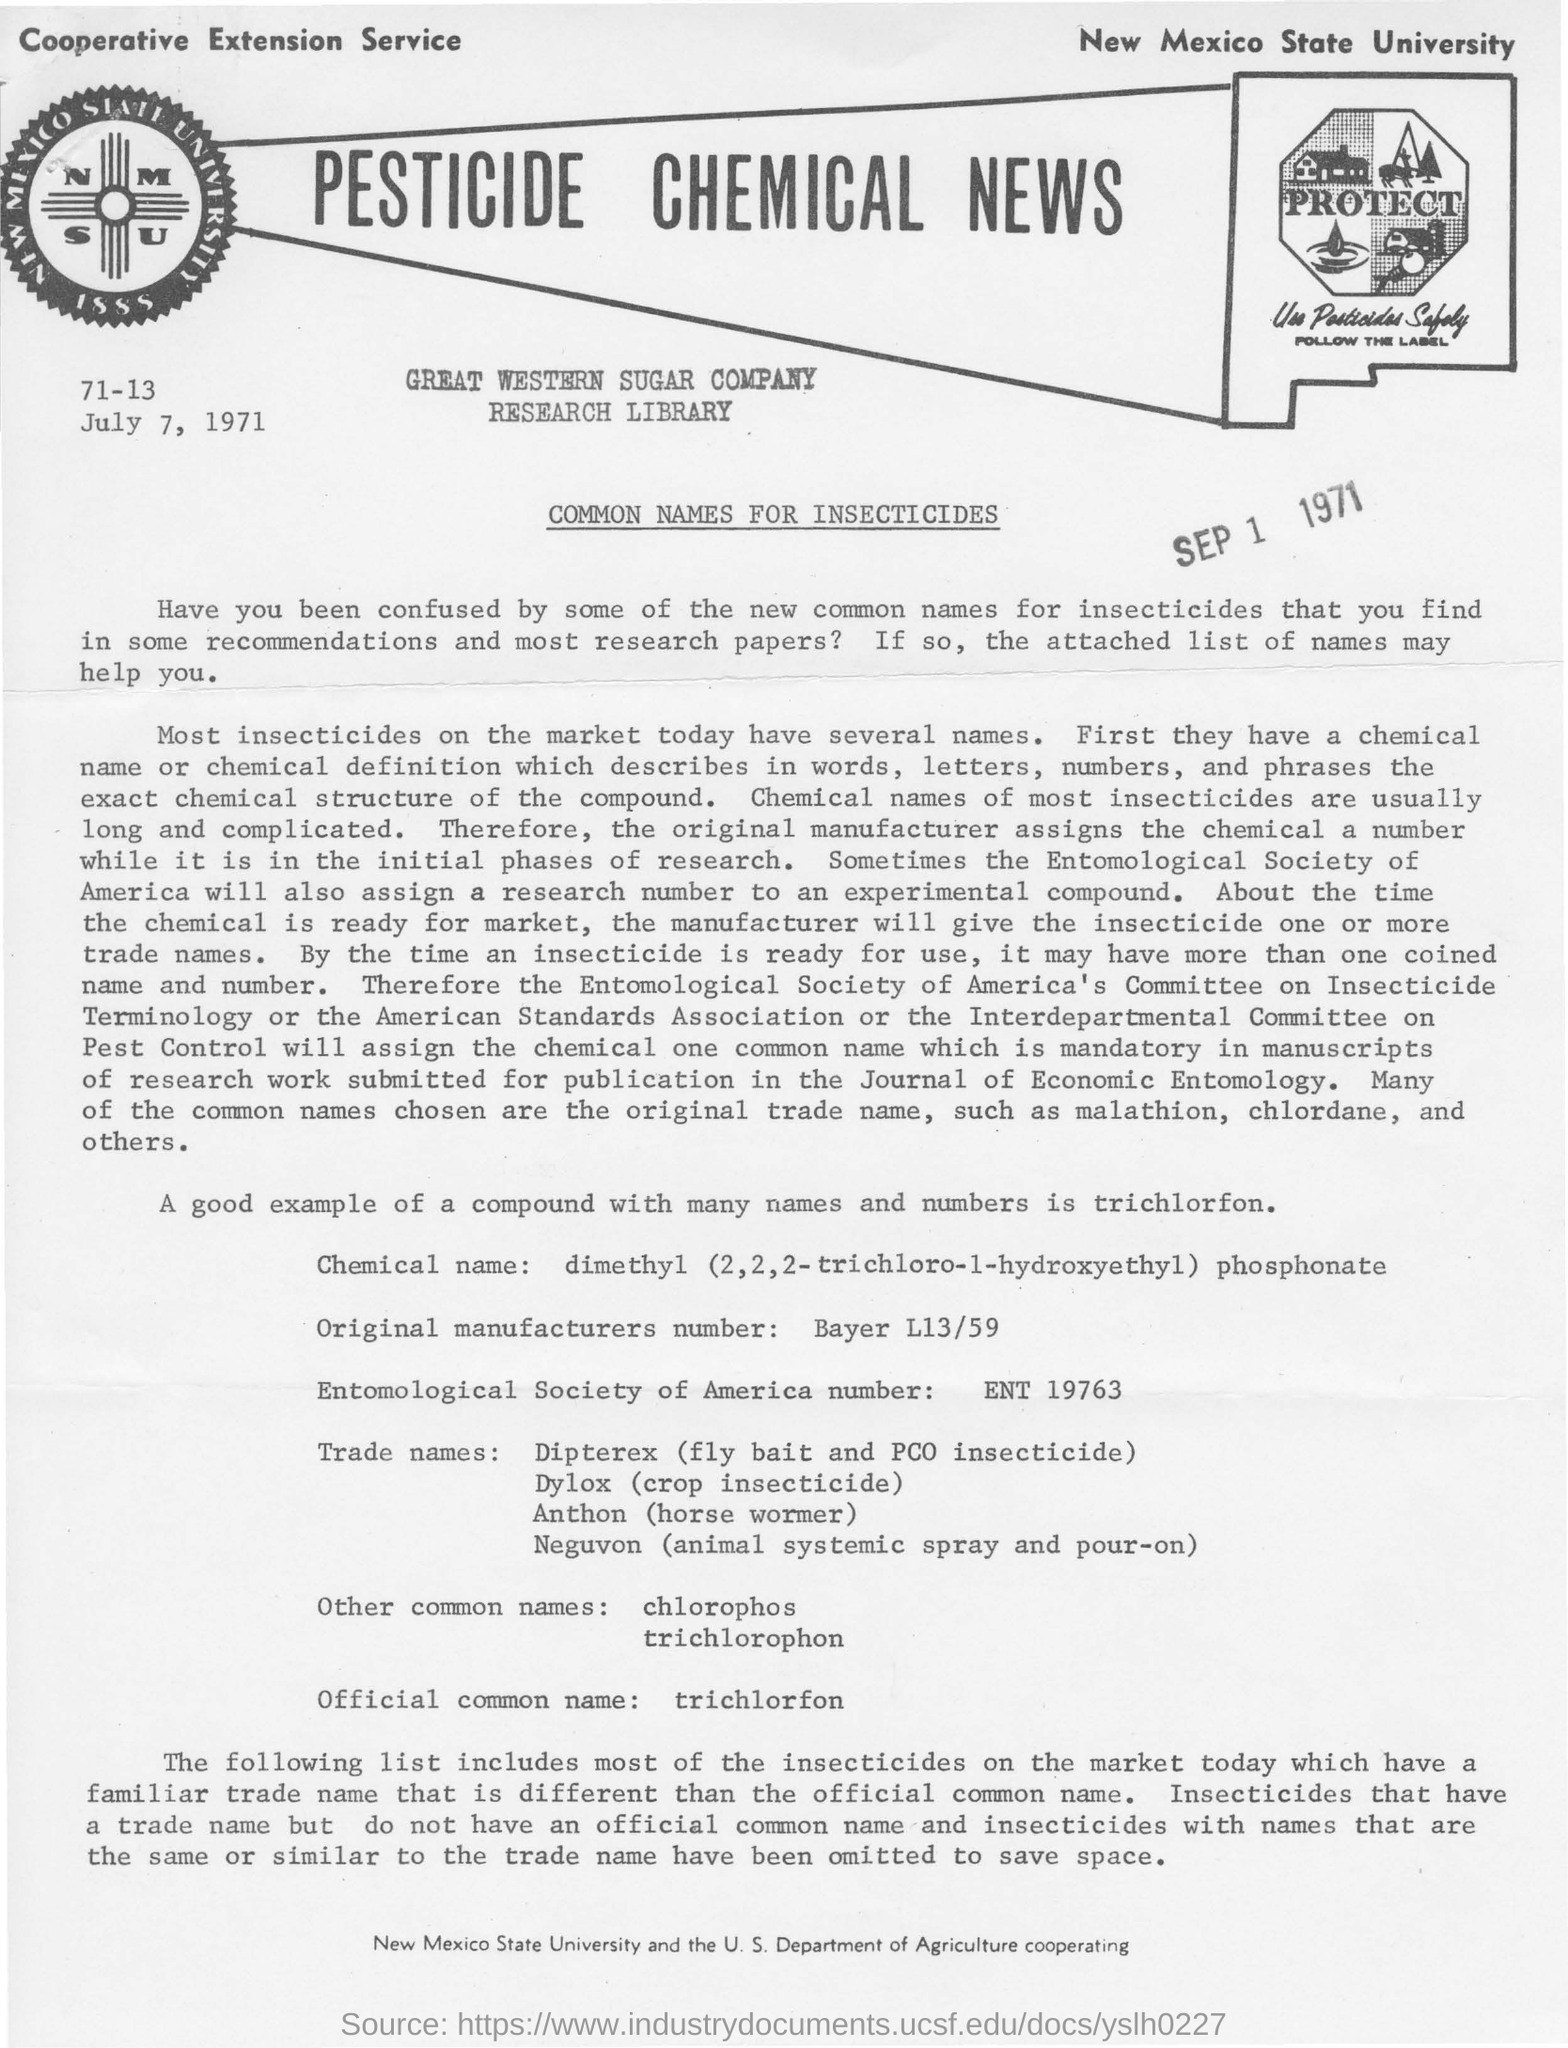What is the pesticides official common name?
Your response must be concise. Trichlorfon. What is the name of the university in the top right corner?
Keep it short and to the point. New Mexico State University. What is the title of the document?
Keep it short and to the point. PESTICIDE CHEMICAL NEWS. 